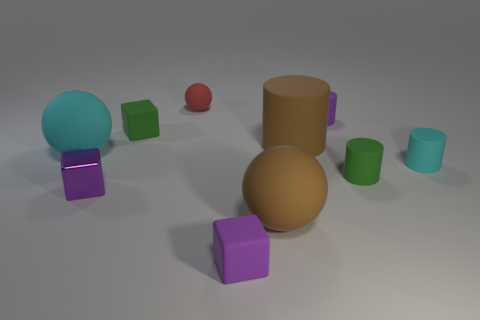There is a red object that is made of the same material as the cyan cylinder; what is its shape?
Provide a short and direct response. Sphere. Is there anything else that has the same color as the tiny sphere?
Provide a succinct answer. No. What color is the block in front of the brown rubber sphere?
Make the answer very short. Purple. Is the color of the rubber sphere to the right of the tiny purple rubber cube the same as the large cylinder?
Your answer should be compact. Yes. How many purple shiny things are the same size as the brown rubber cylinder?
Your answer should be very brief. 0. There is a red thing; what shape is it?
Make the answer very short. Sphere. There is a matte ball that is both to the right of the green rubber cube and in front of the large brown cylinder; what is its size?
Your answer should be compact. Large. There is a green object that is right of the purple cylinder; what is its material?
Your answer should be compact. Rubber. Do the small metal block and the tiny cylinder that is behind the large cyan rubber object have the same color?
Your answer should be very brief. Yes. What number of things are either purple things that are in front of the small green cube or big rubber things that are in front of the shiny block?
Provide a succinct answer. 3. 